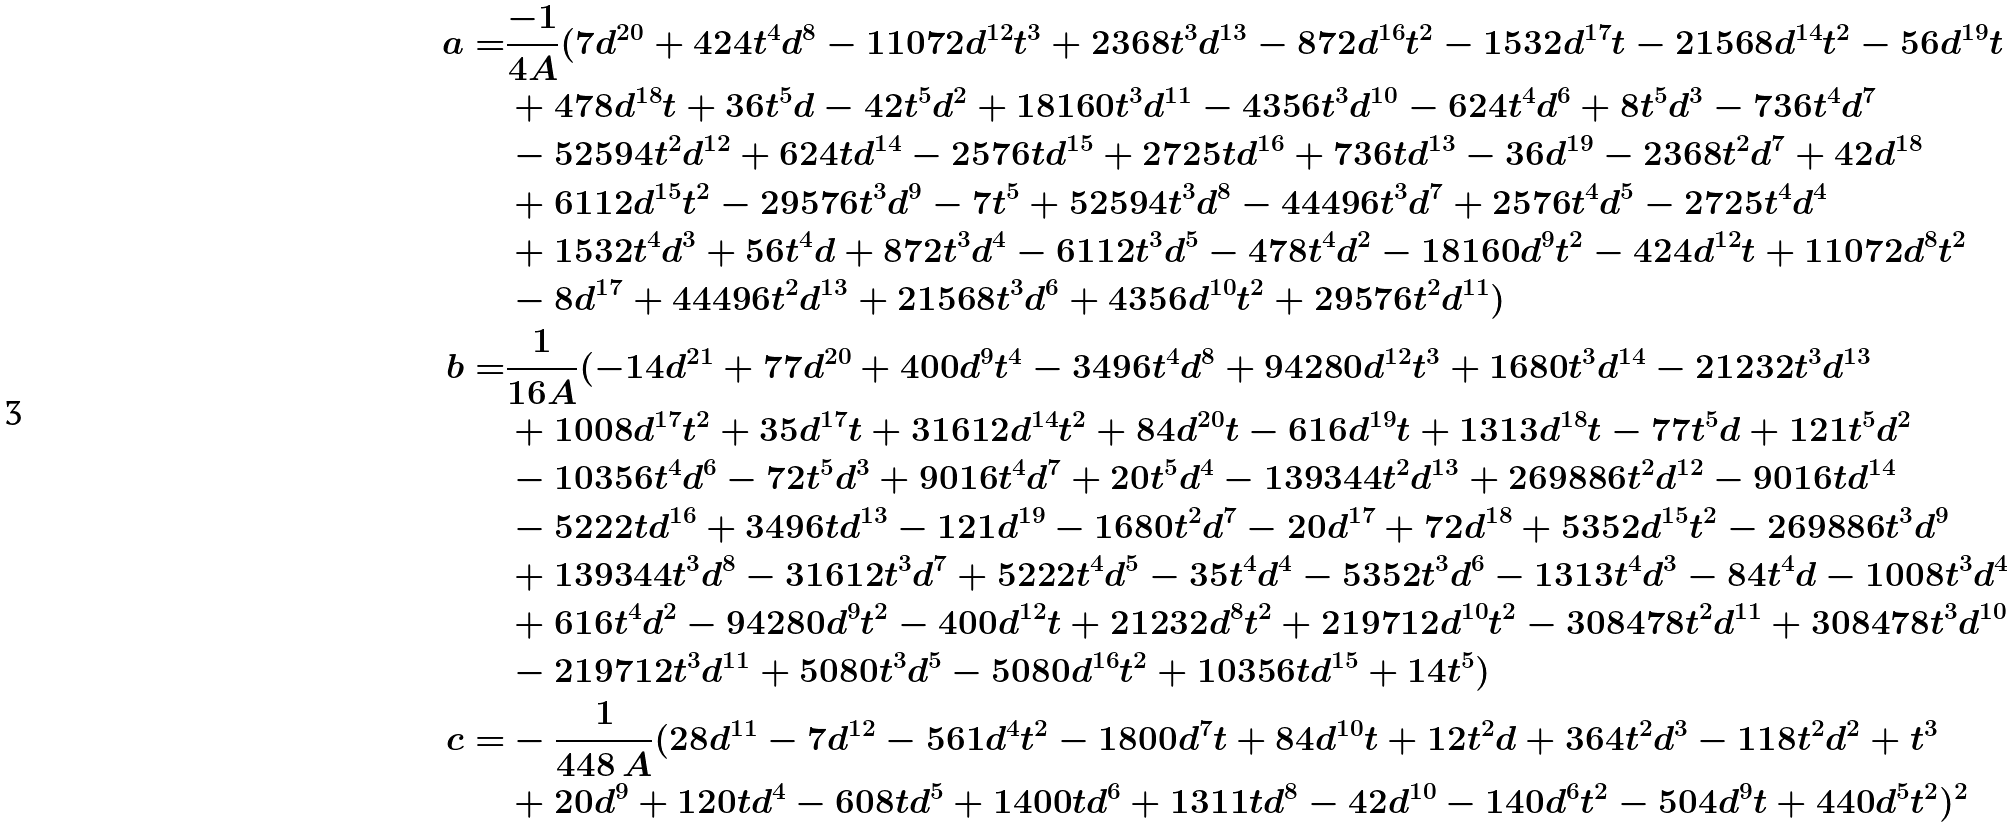Convert formula to latex. <formula><loc_0><loc_0><loc_500><loc_500>a = & \frac { - 1 } { 4 A } ( 7 d ^ { 2 0 } + 4 2 4 t ^ { 4 } d ^ { 8 } - 1 1 0 7 2 d ^ { 1 2 } t ^ { 3 } + 2 3 6 8 t ^ { 3 } d ^ { 1 3 } - 8 7 2 d ^ { 1 6 } t ^ { 2 } - 1 5 3 2 d ^ { 1 7 } t - 2 1 5 6 8 d ^ { 1 4 } t ^ { 2 } - 5 6 d ^ { 1 9 } t \\ & + 4 7 8 d ^ { 1 8 } t + 3 6 t ^ { 5 } d - 4 2 t ^ { 5 } d ^ { 2 } + 1 8 1 6 0 t ^ { 3 } d ^ { 1 1 } - 4 3 5 6 t ^ { 3 } d ^ { 1 0 } - 6 2 4 t ^ { 4 } d ^ { 6 } + 8 t ^ { 5 } d ^ { 3 } - 7 3 6 t ^ { 4 } d ^ { 7 } \\ & - 5 2 5 9 4 t ^ { 2 } d ^ { 1 2 } + 6 2 4 t d ^ { 1 4 } - 2 5 7 6 t d ^ { 1 5 } + 2 7 2 5 t d ^ { 1 6 } + 7 3 6 t d ^ { 1 3 } - 3 6 d ^ { 1 9 } - 2 3 6 8 t ^ { 2 } d ^ { 7 } + 4 2 d ^ { 1 8 } \\ & + 6 1 1 2 d ^ { 1 5 } t ^ { 2 } - 2 9 5 7 6 t ^ { 3 } d ^ { 9 } - 7 t ^ { 5 } + 5 2 5 9 4 t ^ { 3 } d ^ { 8 } - 4 4 4 9 6 t ^ { 3 } d ^ { 7 } + 2 5 7 6 t ^ { 4 } d ^ { 5 } - 2 7 2 5 t ^ { 4 } d ^ { 4 } \\ & + 1 5 3 2 t ^ { 4 } d ^ { 3 } + 5 6 t ^ { 4 } d + 8 7 2 t ^ { 3 } d ^ { 4 } - 6 1 1 2 t ^ { 3 } d ^ { 5 } - 4 7 8 t ^ { 4 } d ^ { 2 } - 1 8 1 6 0 d ^ { 9 } t ^ { 2 } - 4 2 4 d ^ { 1 2 } t + 1 1 0 7 2 d ^ { 8 } t ^ { 2 } \\ & - 8 d ^ { 1 7 } + 4 4 4 9 6 t ^ { 2 } d ^ { 1 3 } + 2 1 5 6 8 t ^ { 3 } d ^ { 6 } + 4 3 5 6 d ^ { 1 0 } t ^ { 2 } + 2 9 5 7 6 t ^ { 2 } d ^ { 1 1 } ) \\ b = & \frac { 1 } { 1 6 A } ( - 1 4 d ^ { 2 1 } + 7 7 d ^ { 2 0 } + 4 0 0 d ^ { 9 } t ^ { 4 } - 3 4 9 6 t ^ { 4 } d ^ { 8 } + 9 4 2 8 0 d ^ { 1 2 } t ^ { 3 } + 1 6 8 0 t ^ { 3 } d ^ { 1 4 } - 2 1 2 3 2 t ^ { 3 } d ^ { 1 3 } \\ & + 1 0 0 8 d ^ { 1 7 } t ^ { 2 } + 3 5 d ^ { 1 7 } t + 3 1 6 1 2 d ^ { 1 4 } t ^ { 2 } + 8 4 d ^ { 2 0 } t - 6 1 6 d ^ { 1 9 } t + 1 3 1 3 d ^ { 1 8 } t - 7 7 t ^ { 5 } d + 1 2 1 t ^ { 5 } d ^ { 2 } \\ & - 1 0 3 5 6 t ^ { 4 } d ^ { 6 } - 7 2 t ^ { 5 } d ^ { 3 } + 9 0 1 6 t ^ { 4 } d ^ { 7 } + 2 0 t ^ { 5 } d ^ { 4 } - 1 3 9 3 4 4 t ^ { 2 } d ^ { 1 3 } + 2 6 9 8 8 6 t ^ { 2 } d ^ { 1 2 } - 9 0 1 6 t d ^ { 1 4 } \\ & - 5 2 2 2 t d ^ { 1 6 } + 3 4 9 6 t d ^ { 1 3 } - 1 2 1 d ^ { 1 9 } - 1 6 8 0 t ^ { 2 } d ^ { 7 } - 2 0 d ^ { 1 7 } + 7 2 d ^ { 1 8 } + 5 3 5 2 d ^ { 1 5 } t ^ { 2 } - 2 6 9 8 8 6 t ^ { 3 } d ^ { 9 } \\ & + 1 3 9 3 4 4 t ^ { 3 } d ^ { 8 } - 3 1 6 1 2 t ^ { 3 } d ^ { 7 } + 5 2 2 2 t ^ { 4 } d ^ { 5 } - 3 5 t ^ { 4 } d ^ { 4 } - 5 3 5 2 t ^ { 3 } d ^ { 6 } - 1 3 1 3 t ^ { 4 } d ^ { 3 } - 8 4 t ^ { 4 } d - 1 0 0 8 t ^ { 3 } d ^ { 4 } \\ & + 6 1 6 t ^ { 4 } d ^ { 2 } - 9 4 2 8 0 d ^ { 9 } t ^ { 2 } - 4 0 0 d ^ { 1 2 } t + 2 1 2 3 2 d ^ { 8 } t ^ { 2 } + 2 1 9 7 1 2 d ^ { 1 0 } t ^ { 2 } - 3 0 8 4 7 8 t ^ { 2 } d ^ { 1 1 } + 3 0 8 4 7 8 t ^ { 3 } d ^ { 1 0 } \\ & - 2 1 9 7 1 2 t ^ { 3 } d ^ { 1 1 } + 5 0 8 0 t ^ { 3 } d ^ { 5 } - 5 0 8 0 d ^ { 1 6 } t ^ { 2 } + 1 0 3 5 6 t d ^ { 1 5 } + 1 4 t ^ { 5 } ) \\ c = & - \frac { 1 } { 4 4 8 \, A } ( 2 8 d ^ { 1 1 } - 7 d ^ { 1 2 } - 5 6 1 d ^ { 4 } t ^ { 2 } - 1 8 0 0 d ^ { 7 } t + 8 4 d ^ { 1 0 } t + 1 2 t ^ { 2 } d + 3 6 4 t ^ { 2 } d ^ { 3 } - 1 1 8 t ^ { 2 } d ^ { 2 } + t ^ { 3 } \\ & + 2 0 d ^ { 9 } + 1 2 0 t d ^ { 4 } - 6 0 8 t d ^ { 5 } + 1 4 0 0 t d ^ { 6 } + 1 3 1 1 t d ^ { 8 } - 4 2 d ^ { 1 0 } - 1 4 0 d ^ { 6 } t ^ { 2 } - 5 0 4 d ^ { 9 } t + 4 4 0 d ^ { 5 } t ^ { 2 } ) ^ { 2 } \\</formula> 